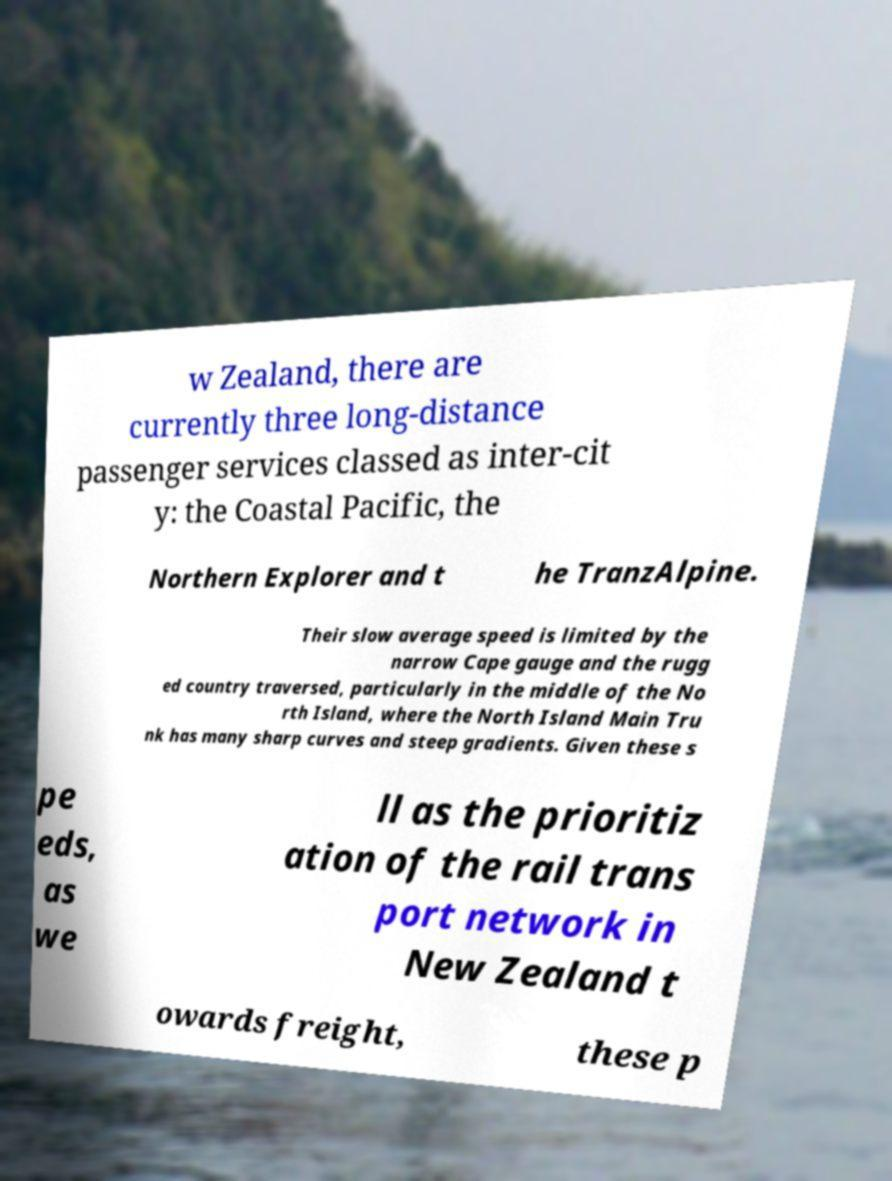Please read and relay the text visible in this image. What does it say? w Zealand, there are currently three long-distance passenger services classed as inter-cit y: the Coastal Pacific, the Northern Explorer and t he TranzAlpine. Their slow average speed is limited by the narrow Cape gauge and the rugg ed country traversed, particularly in the middle of the No rth Island, where the North Island Main Tru nk has many sharp curves and steep gradients. Given these s pe eds, as we ll as the prioritiz ation of the rail trans port network in New Zealand t owards freight, these p 